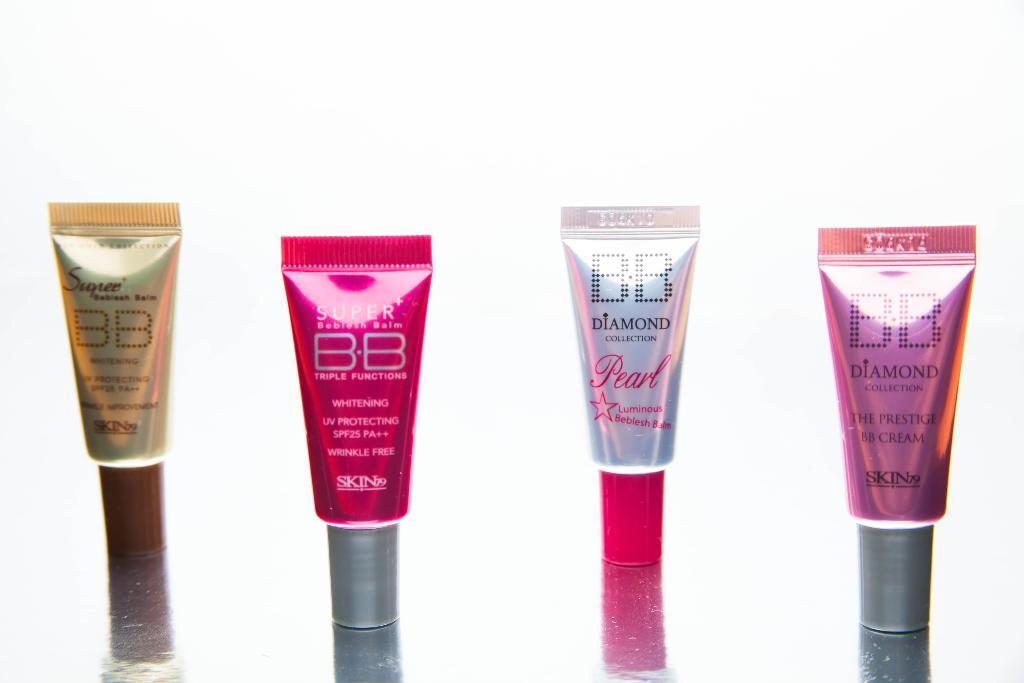What kind of cream is this?
Make the answer very short. Bb. What collection are a couple of these creams from?
Ensure brevity in your answer.  Bb. 